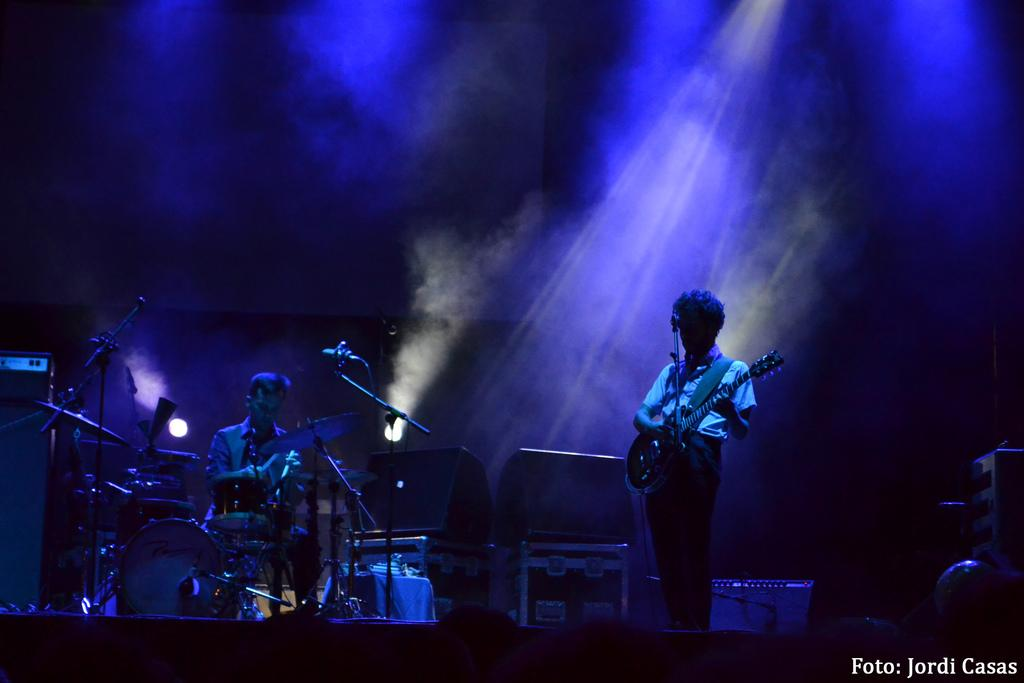How many people are in the image? There are two men in the image. What are the men doing in the image? One man is standing and holding a guitar, while the other man is sitting in front of a drum set. What objects are associated with the men in the image? The standing man has a guitar, and the sitting man is in front of a drum set. What animals can be seen in the image? There are mice in front of the men. What type of wool is being used to create a summer hat in the image? There is no wool or summer hat present in the image. 